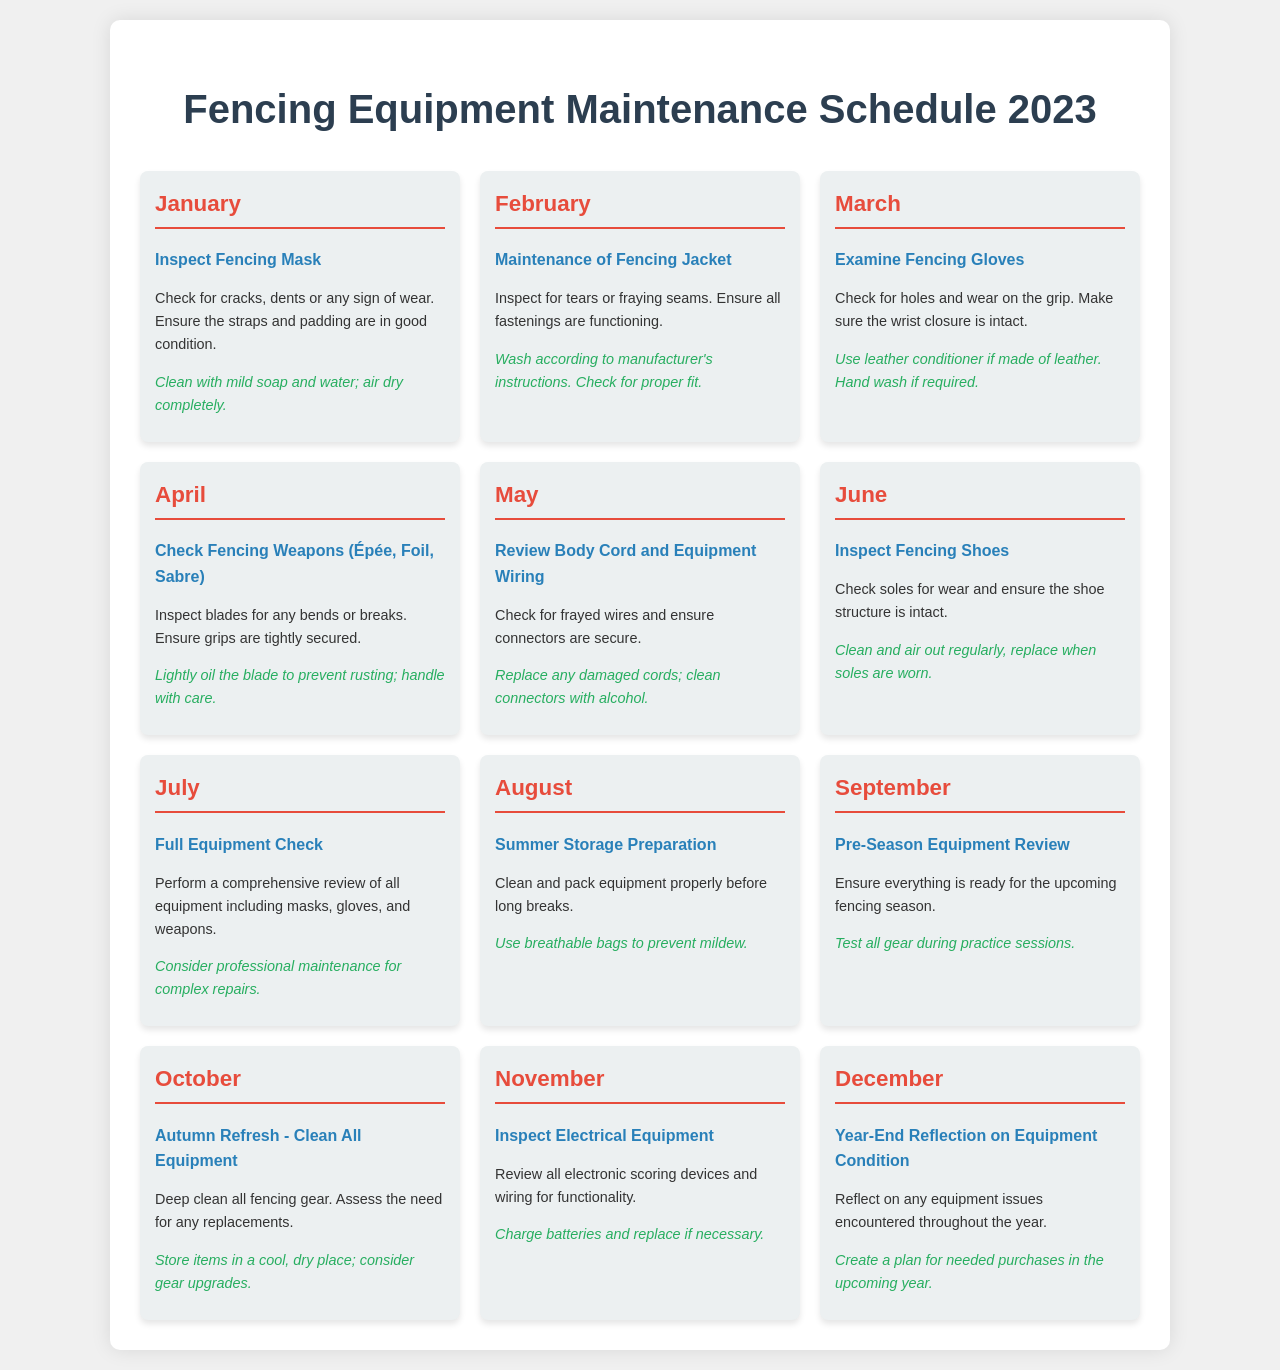What maintenance task is scheduled for January? The document lists "Inspect Fencing Mask" as the task for January.
Answer: Inspect Fencing Mask What is the recommendation for inspecting fencing gloves? The recommendation for inspecting fencing gloves is to use leather conditioner if made of leather and hand wash if required.
Answer: Use leather conditioner if made of leather. Hand wash if required Which month involves a full equipment check? The month of July is when a full equipment check is scheduled.
Answer: July How often should the electrical equipment be inspected? The inspection of electrical equipment is scheduled for November, which suggests once a year.
Answer: Once a year What should be checked during the examination of fencing weapons? The inspection of fencing weapons involves checking blades for bends or breaks and ensuring grips are tightly secured.
Answer: Blades for bends or breaks and grips are tightly secured What is the task for October? The task for October is "Autumn Refresh - Clean All Equipment."
Answer: Autumn Refresh - Clean All Equipment What is the recommendation for summer storage preparation? The recommendation for summer storage preparation is to use breathable bags to prevent mildew.
Answer: Use breathable bags to prevent mildew What should be done during the pre-season equipment review? During the pre-season equipment review in September, it is recommended to test all gear during practice sessions.
Answer: Test all gear during practice sessions 